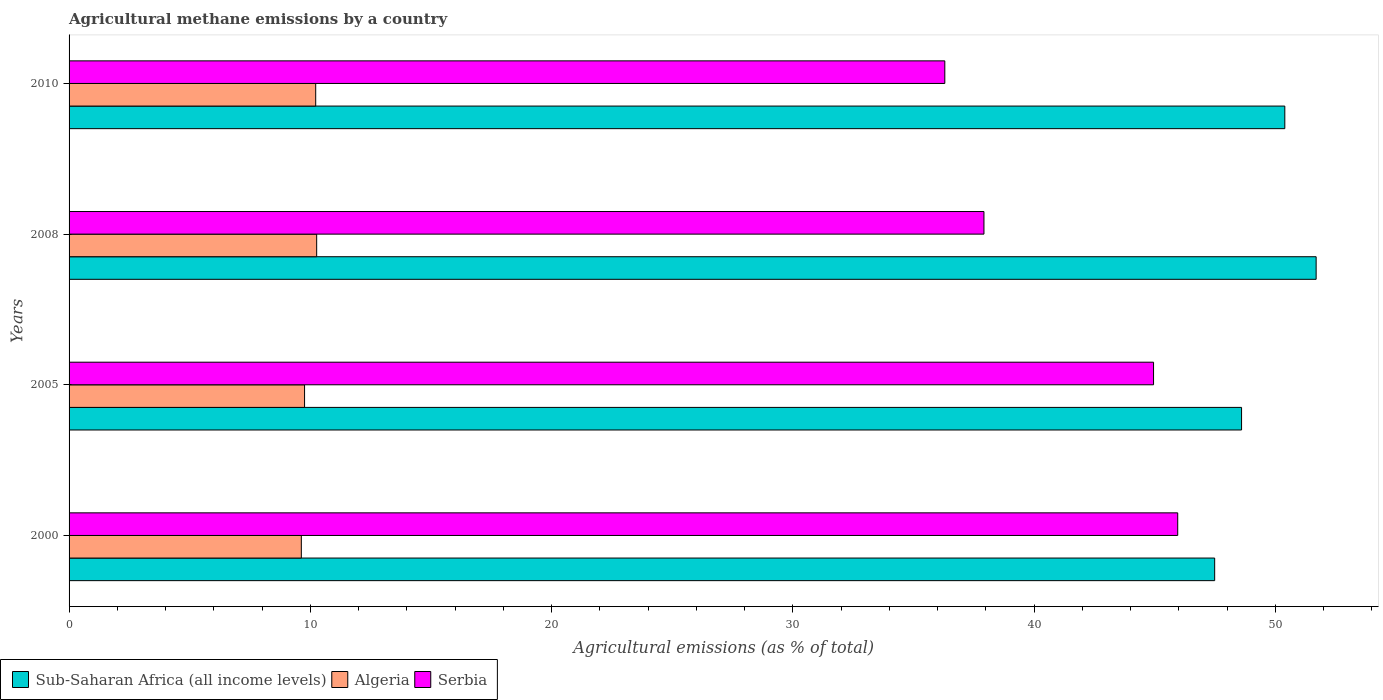How many groups of bars are there?
Give a very brief answer. 4. Are the number of bars on each tick of the Y-axis equal?
Your answer should be compact. Yes. How many bars are there on the 2nd tick from the top?
Offer a very short reply. 3. What is the label of the 4th group of bars from the top?
Your answer should be very brief. 2000. In how many cases, is the number of bars for a given year not equal to the number of legend labels?
Give a very brief answer. 0. What is the amount of agricultural methane emitted in Sub-Saharan Africa (all income levels) in 2000?
Offer a very short reply. 47.48. Across all years, what is the maximum amount of agricultural methane emitted in Algeria?
Keep it short and to the point. 10.26. Across all years, what is the minimum amount of agricultural methane emitted in Algeria?
Ensure brevity in your answer.  9.63. In which year was the amount of agricultural methane emitted in Algeria minimum?
Offer a terse response. 2000. What is the total amount of agricultural methane emitted in Serbia in the graph?
Give a very brief answer. 165.12. What is the difference between the amount of agricultural methane emitted in Serbia in 2005 and that in 2010?
Provide a succinct answer. 8.65. What is the difference between the amount of agricultural methane emitted in Sub-Saharan Africa (all income levels) in 2005 and the amount of agricultural methane emitted in Algeria in 2008?
Provide a succinct answer. 38.34. What is the average amount of agricultural methane emitted in Serbia per year?
Ensure brevity in your answer.  41.28. In the year 2000, what is the difference between the amount of agricultural methane emitted in Sub-Saharan Africa (all income levels) and amount of agricultural methane emitted in Serbia?
Give a very brief answer. 1.53. In how many years, is the amount of agricultural methane emitted in Sub-Saharan Africa (all income levels) greater than 52 %?
Make the answer very short. 0. What is the ratio of the amount of agricultural methane emitted in Algeria in 2008 to that in 2010?
Offer a very short reply. 1. Is the difference between the amount of agricultural methane emitted in Sub-Saharan Africa (all income levels) in 2008 and 2010 greater than the difference between the amount of agricultural methane emitted in Serbia in 2008 and 2010?
Keep it short and to the point. No. What is the difference between the highest and the second highest amount of agricultural methane emitted in Serbia?
Offer a terse response. 1. What is the difference between the highest and the lowest amount of agricultural methane emitted in Sub-Saharan Africa (all income levels)?
Your answer should be very brief. 4.21. Is the sum of the amount of agricultural methane emitted in Sub-Saharan Africa (all income levels) in 2000 and 2005 greater than the maximum amount of agricultural methane emitted in Algeria across all years?
Make the answer very short. Yes. What does the 2nd bar from the top in 2000 represents?
Give a very brief answer. Algeria. What does the 3rd bar from the bottom in 2000 represents?
Your answer should be compact. Serbia. Are all the bars in the graph horizontal?
Your response must be concise. Yes. What is the difference between two consecutive major ticks on the X-axis?
Keep it short and to the point. 10. Are the values on the major ticks of X-axis written in scientific E-notation?
Make the answer very short. No. Does the graph contain grids?
Offer a terse response. No. How are the legend labels stacked?
Give a very brief answer. Horizontal. What is the title of the graph?
Offer a terse response. Agricultural methane emissions by a country. What is the label or title of the X-axis?
Offer a terse response. Agricultural emissions (as % of total). What is the Agricultural emissions (as % of total) in Sub-Saharan Africa (all income levels) in 2000?
Offer a very short reply. 47.48. What is the Agricultural emissions (as % of total) in Algeria in 2000?
Your response must be concise. 9.63. What is the Agricultural emissions (as % of total) in Serbia in 2000?
Your answer should be compact. 45.95. What is the Agricultural emissions (as % of total) of Sub-Saharan Africa (all income levels) in 2005?
Ensure brevity in your answer.  48.6. What is the Agricultural emissions (as % of total) in Algeria in 2005?
Your response must be concise. 9.76. What is the Agricultural emissions (as % of total) of Serbia in 2005?
Give a very brief answer. 44.95. What is the Agricultural emissions (as % of total) in Sub-Saharan Africa (all income levels) in 2008?
Your response must be concise. 51.69. What is the Agricultural emissions (as % of total) in Algeria in 2008?
Make the answer very short. 10.26. What is the Agricultural emissions (as % of total) of Serbia in 2008?
Your response must be concise. 37.92. What is the Agricultural emissions (as % of total) in Sub-Saharan Africa (all income levels) in 2010?
Ensure brevity in your answer.  50.39. What is the Agricultural emissions (as % of total) in Algeria in 2010?
Provide a succinct answer. 10.22. What is the Agricultural emissions (as % of total) in Serbia in 2010?
Your answer should be compact. 36.3. Across all years, what is the maximum Agricultural emissions (as % of total) in Sub-Saharan Africa (all income levels)?
Give a very brief answer. 51.69. Across all years, what is the maximum Agricultural emissions (as % of total) of Algeria?
Your answer should be very brief. 10.26. Across all years, what is the maximum Agricultural emissions (as % of total) in Serbia?
Keep it short and to the point. 45.95. Across all years, what is the minimum Agricultural emissions (as % of total) in Sub-Saharan Africa (all income levels)?
Your response must be concise. 47.48. Across all years, what is the minimum Agricultural emissions (as % of total) in Algeria?
Offer a terse response. 9.63. Across all years, what is the minimum Agricultural emissions (as % of total) in Serbia?
Give a very brief answer. 36.3. What is the total Agricultural emissions (as % of total) in Sub-Saharan Africa (all income levels) in the graph?
Your response must be concise. 198.16. What is the total Agricultural emissions (as % of total) in Algeria in the graph?
Keep it short and to the point. 39.87. What is the total Agricultural emissions (as % of total) of Serbia in the graph?
Your answer should be very brief. 165.12. What is the difference between the Agricultural emissions (as % of total) of Sub-Saharan Africa (all income levels) in 2000 and that in 2005?
Make the answer very short. -1.12. What is the difference between the Agricultural emissions (as % of total) of Algeria in 2000 and that in 2005?
Your answer should be compact. -0.13. What is the difference between the Agricultural emissions (as % of total) of Sub-Saharan Africa (all income levels) in 2000 and that in 2008?
Your answer should be very brief. -4.21. What is the difference between the Agricultural emissions (as % of total) of Algeria in 2000 and that in 2008?
Keep it short and to the point. -0.64. What is the difference between the Agricultural emissions (as % of total) of Serbia in 2000 and that in 2008?
Your answer should be compact. 8.03. What is the difference between the Agricultural emissions (as % of total) of Sub-Saharan Africa (all income levels) in 2000 and that in 2010?
Offer a very short reply. -2.91. What is the difference between the Agricultural emissions (as % of total) of Algeria in 2000 and that in 2010?
Offer a very short reply. -0.6. What is the difference between the Agricultural emissions (as % of total) in Serbia in 2000 and that in 2010?
Your answer should be very brief. 9.65. What is the difference between the Agricultural emissions (as % of total) in Sub-Saharan Africa (all income levels) in 2005 and that in 2008?
Make the answer very short. -3.09. What is the difference between the Agricultural emissions (as % of total) in Algeria in 2005 and that in 2008?
Ensure brevity in your answer.  -0.5. What is the difference between the Agricultural emissions (as % of total) in Serbia in 2005 and that in 2008?
Ensure brevity in your answer.  7.03. What is the difference between the Agricultural emissions (as % of total) in Sub-Saharan Africa (all income levels) in 2005 and that in 2010?
Keep it short and to the point. -1.79. What is the difference between the Agricultural emissions (as % of total) in Algeria in 2005 and that in 2010?
Provide a succinct answer. -0.46. What is the difference between the Agricultural emissions (as % of total) of Serbia in 2005 and that in 2010?
Provide a succinct answer. 8.65. What is the difference between the Agricultural emissions (as % of total) of Sub-Saharan Africa (all income levels) in 2008 and that in 2010?
Your response must be concise. 1.3. What is the difference between the Agricultural emissions (as % of total) of Algeria in 2008 and that in 2010?
Ensure brevity in your answer.  0.04. What is the difference between the Agricultural emissions (as % of total) in Serbia in 2008 and that in 2010?
Make the answer very short. 1.62. What is the difference between the Agricultural emissions (as % of total) in Sub-Saharan Africa (all income levels) in 2000 and the Agricultural emissions (as % of total) in Algeria in 2005?
Offer a terse response. 37.72. What is the difference between the Agricultural emissions (as % of total) of Sub-Saharan Africa (all income levels) in 2000 and the Agricultural emissions (as % of total) of Serbia in 2005?
Your response must be concise. 2.53. What is the difference between the Agricultural emissions (as % of total) of Algeria in 2000 and the Agricultural emissions (as % of total) of Serbia in 2005?
Your answer should be very brief. -35.32. What is the difference between the Agricultural emissions (as % of total) in Sub-Saharan Africa (all income levels) in 2000 and the Agricultural emissions (as % of total) in Algeria in 2008?
Ensure brevity in your answer.  37.22. What is the difference between the Agricultural emissions (as % of total) in Sub-Saharan Africa (all income levels) in 2000 and the Agricultural emissions (as % of total) in Serbia in 2008?
Make the answer very short. 9.56. What is the difference between the Agricultural emissions (as % of total) in Algeria in 2000 and the Agricultural emissions (as % of total) in Serbia in 2008?
Provide a short and direct response. -28.29. What is the difference between the Agricultural emissions (as % of total) in Sub-Saharan Africa (all income levels) in 2000 and the Agricultural emissions (as % of total) in Algeria in 2010?
Ensure brevity in your answer.  37.26. What is the difference between the Agricultural emissions (as % of total) of Sub-Saharan Africa (all income levels) in 2000 and the Agricultural emissions (as % of total) of Serbia in 2010?
Provide a short and direct response. 11.19. What is the difference between the Agricultural emissions (as % of total) of Algeria in 2000 and the Agricultural emissions (as % of total) of Serbia in 2010?
Provide a succinct answer. -26.67. What is the difference between the Agricultural emissions (as % of total) in Sub-Saharan Africa (all income levels) in 2005 and the Agricultural emissions (as % of total) in Algeria in 2008?
Your answer should be very brief. 38.34. What is the difference between the Agricultural emissions (as % of total) in Sub-Saharan Africa (all income levels) in 2005 and the Agricultural emissions (as % of total) in Serbia in 2008?
Your response must be concise. 10.68. What is the difference between the Agricultural emissions (as % of total) in Algeria in 2005 and the Agricultural emissions (as % of total) in Serbia in 2008?
Make the answer very short. -28.16. What is the difference between the Agricultural emissions (as % of total) in Sub-Saharan Africa (all income levels) in 2005 and the Agricultural emissions (as % of total) in Algeria in 2010?
Give a very brief answer. 38.38. What is the difference between the Agricultural emissions (as % of total) of Sub-Saharan Africa (all income levels) in 2005 and the Agricultural emissions (as % of total) of Serbia in 2010?
Offer a very short reply. 12.3. What is the difference between the Agricultural emissions (as % of total) in Algeria in 2005 and the Agricultural emissions (as % of total) in Serbia in 2010?
Keep it short and to the point. -26.54. What is the difference between the Agricultural emissions (as % of total) in Sub-Saharan Africa (all income levels) in 2008 and the Agricultural emissions (as % of total) in Algeria in 2010?
Your response must be concise. 41.47. What is the difference between the Agricultural emissions (as % of total) in Sub-Saharan Africa (all income levels) in 2008 and the Agricultural emissions (as % of total) in Serbia in 2010?
Offer a very short reply. 15.39. What is the difference between the Agricultural emissions (as % of total) of Algeria in 2008 and the Agricultural emissions (as % of total) of Serbia in 2010?
Make the answer very short. -26.04. What is the average Agricultural emissions (as % of total) in Sub-Saharan Africa (all income levels) per year?
Provide a succinct answer. 49.54. What is the average Agricultural emissions (as % of total) of Algeria per year?
Ensure brevity in your answer.  9.97. What is the average Agricultural emissions (as % of total) of Serbia per year?
Ensure brevity in your answer.  41.28. In the year 2000, what is the difference between the Agricultural emissions (as % of total) of Sub-Saharan Africa (all income levels) and Agricultural emissions (as % of total) of Algeria?
Your answer should be compact. 37.86. In the year 2000, what is the difference between the Agricultural emissions (as % of total) in Sub-Saharan Africa (all income levels) and Agricultural emissions (as % of total) in Serbia?
Provide a short and direct response. 1.53. In the year 2000, what is the difference between the Agricultural emissions (as % of total) of Algeria and Agricultural emissions (as % of total) of Serbia?
Offer a terse response. -36.33. In the year 2005, what is the difference between the Agricultural emissions (as % of total) of Sub-Saharan Africa (all income levels) and Agricultural emissions (as % of total) of Algeria?
Your answer should be compact. 38.84. In the year 2005, what is the difference between the Agricultural emissions (as % of total) in Sub-Saharan Africa (all income levels) and Agricultural emissions (as % of total) in Serbia?
Offer a very short reply. 3.65. In the year 2005, what is the difference between the Agricultural emissions (as % of total) in Algeria and Agricultural emissions (as % of total) in Serbia?
Offer a very short reply. -35.19. In the year 2008, what is the difference between the Agricultural emissions (as % of total) of Sub-Saharan Africa (all income levels) and Agricultural emissions (as % of total) of Algeria?
Your answer should be very brief. 41.43. In the year 2008, what is the difference between the Agricultural emissions (as % of total) of Sub-Saharan Africa (all income levels) and Agricultural emissions (as % of total) of Serbia?
Your response must be concise. 13.77. In the year 2008, what is the difference between the Agricultural emissions (as % of total) in Algeria and Agricultural emissions (as % of total) in Serbia?
Your answer should be compact. -27.66. In the year 2010, what is the difference between the Agricultural emissions (as % of total) of Sub-Saharan Africa (all income levels) and Agricultural emissions (as % of total) of Algeria?
Ensure brevity in your answer.  40.17. In the year 2010, what is the difference between the Agricultural emissions (as % of total) of Sub-Saharan Africa (all income levels) and Agricultural emissions (as % of total) of Serbia?
Give a very brief answer. 14.09. In the year 2010, what is the difference between the Agricultural emissions (as % of total) in Algeria and Agricultural emissions (as % of total) in Serbia?
Your answer should be compact. -26.08. What is the ratio of the Agricultural emissions (as % of total) of Sub-Saharan Africa (all income levels) in 2000 to that in 2005?
Make the answer very short. 0.98. What is the ratio of the Agricultural emissions (as % of total) in Algeria in 2000 to that in 2005?
Make the answer very short. 0.99. What is the ratio of the Agricultural emissions (as % of total) of Serbia in 2000 to that in 2005?
Provide a short and direct response. 1.02. What is the ratio of the Agricultural emissions (as % of total) of Sub-Saharan Africa (all income levels) in 2000 to that in 2008?
Make the answer very short. 0.92. What is the ratio of the Agricultural emissions (as % of total) of Algeria in 2000 to that in 2008?
Your response must be concise. 0.94. What is the ratio of the Agricultural emissions (as % of total) of Serbia in 2000 to that in 2008?
Ensure brevity in your answer.  1.21. What is the ratio of the Agricultural emissions (as % of total) of Sub-Saharan Africa (all income levels) in 2000 to that in 2010?
Provide a short and direct response. 0.94. What is the ratio of the Agricultural emissions (as % of total) in Algeria in 2000 to that in 2010?
Keep it short and to the point. 0.94. What is the ratio of the Agricultural emissions (as % of total) of Serbia in 2000 to that in 2010?
Offer a terse response. 1.27. What is the ratio of the Agricultural emissions (as % of total) in Sub-Saharan Africa (all income levels) in 2005 to that in 2008?
Provide a succinct answer. 0.94. What is the ratio of the Agricultural emissions (as % of total) of Algeria in 2005 to that in 2008?
Provide a short and direct response. 0.95. What is the ratio of the Agricultural emissions (as % of total) of Serbia in 2005 to that in 2008?
Keep it short and to the point. 1.19. What is the ratio of the Agricultural emissions (as % of total) of Sub-Saharan Africa (all income levels) in 2005 to that in 2010?
Give a very brief answer. 0.96. What is the ratio of the Agricultural emissions (as % of total) in Algeria in 2005 to that in 2010?
Your answer should be very brief. 0.95. What is the ratio of the Agricultural emissions (as % of total) of Serbia in 2005 to that in 2010?
Provide a short and direct response. 1.24. What is the ratio of the Agricultural emissions (as % of total) in Sub-Saharan Africa (all income levels) in 2008 to that in 2010?
Provide a short and direct response. 1.03. What is the ratio of the Agricultural emissions (as % of total) of Serbia in 2008 to that in 2010?
Your answer should be compact. 1.04. What is the difference between the highest and the second highest Agricultural emissions (as % of total) of Sub-Saharan Africa (all income levels)?
Ensure brevity in your answer.  1.3. What is the difference between the highest and the second highest Agricultural emissions (as % of total) of Algeria?
Offer a very short reply. 0.04. What is the difference between the highest and the lowest Agricultural emissions (as % of total) in Sub-Saharan Africa (all income levels)?
Offer a very short reply. 4.21. What is the difference between the highest and the lowest Agricultural emissions (as % of total) in Algeria?
Your response must be concise. 0.64. What is the difference between the highest and the lowest Agricultural emissions (as % of total) in Serbia?
Ensure brevity in your answer.  9.65. 